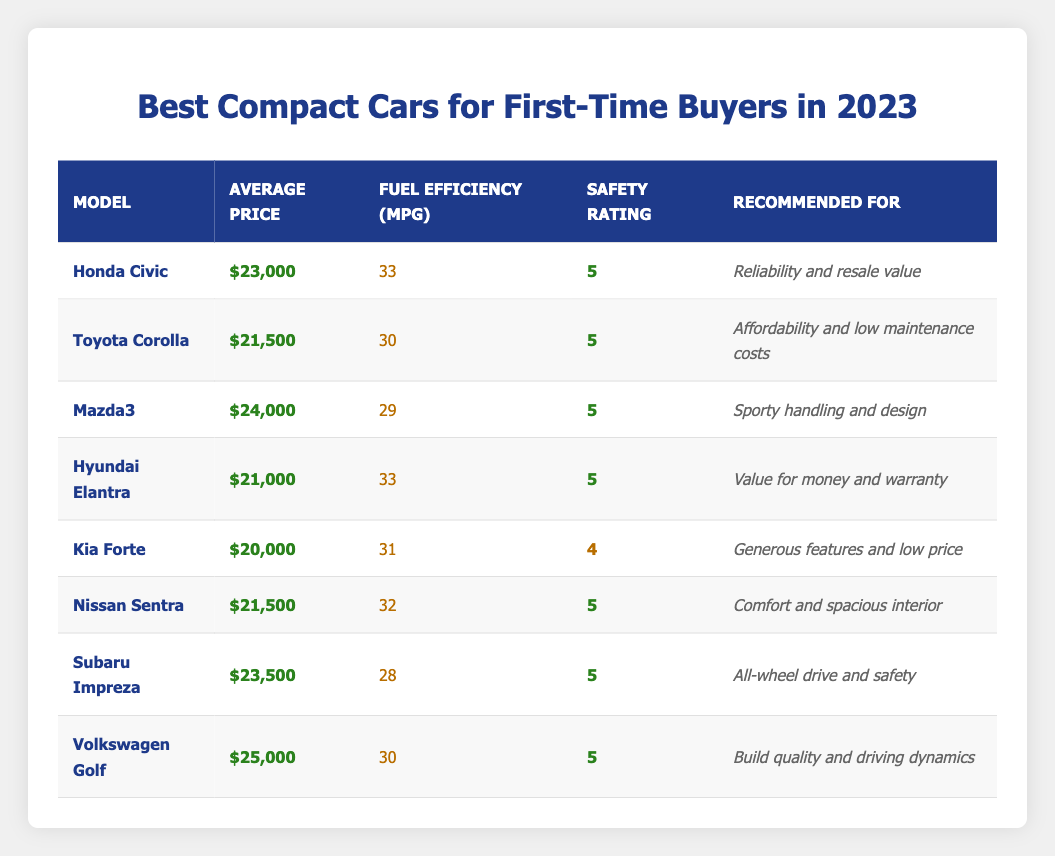What is the average price of the Honda Civic? The table lists the average price of the Honda Civic as $23,000.
Answer: $23,000 Which compact car has the lowest average price? The Kia Forte has the lowest average price listed in the table, which is $20,000.
Answer: $20,000 How many cars have a safety rating of 5? According to the table, there are 6 cars with a safety rating of 5: Honda Civic, Toyota Corolla, Mazda3, Hyundai Elantra, Nissan Sentra, Subaru Impreza, and Volkswagen Golf.
Answer: 6 What is the fuel efficiency of the Hyundai Elantra? The table shows that the fuel efficiency of the Hyundai Elantra is 33 MPG.
Answer: 33 MPG Is the Toyota Corolla more expensive than the Nissan Sentra? The average price of the Toyota Corolla is $21,500, while the Nissan Sentra is also $21,500. Thus, they are equal; neither is more expensive.
Answer: No What is the average price of the cars that have a safety rating of 5? The prices of the cars with safety rating 5 are: $23,000 (Honda Civic), $21,500 (Toyota Corolla), $24,000 (Mazda3), $21,000 (Hyundai Elantra), $21,500 (Nissan Sentra), $23,500 (Subaru Impreza), and $25,000 (Volkswagen Golf). The sum is $23,000 + $21,500 + $24,000 + $21,000 + $21,500 + $23,500 + $25,000 = $  160,500. There are 7 cars, so the average price is $160,500 / 7 ≈ $22,643.
Answer: Approximately $22,643 Which car has the best fuel efficiency among those with an average price under $22,000? Among the cars listed, only the Hyundai Elantra and Kia Forte are under $22,000. The Hyundai Elantra has a fuel efficiency of 33 MPG, while the Kia Forte has 31 MPG, making Hyundai Elantra the best.
Answer: Hyundai Elantra What is the price difference between the Mazda3 and the Subaru Impreza? The average price of the Mazda3 is $24,000 and the Subaru Impreza is $23,500. The difference is calculated as $24,000 - $23,500 = $500.
Answer: $500 Are all compact cars featured in the table recommended for safety? Yes, all cars listed have a safety rating of at least 4, with 6 out of 8 cars rated at 5, indicating overall safety recommendations.
Answer: Yes 